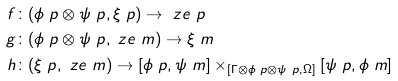<formula> <loc_0><loc_0><loc_500><loc_500>f & \colon ( \phi \ p \otimes \psi \ p , \xi \ p ) \to \ z e \ p \\ g & \colon ( \phi \ p \otimes \psi \ p , \ z e \ m ) \to \xi \ m \\ h & \colon ( \xi \ p , \ z e \ m ) \to [ \phi \ p , \psi \ m ] \times _ { [ \Gamma \otimes \phi \ p \otimes \psi \ p , \Omega ] } [ \psi \ p , \phi \ m ]</formula> 